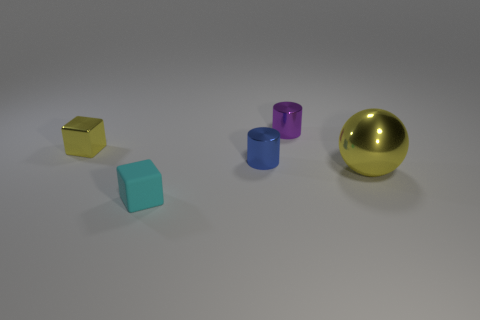Add 5 big brown cylinders. How many objects exist? 10 Subtract all balls. How many objects are left? 4 Add 3 small gray objects. How many small gray objects exist? 3 Subtract 1 blue cylinders. How many objects are left? 4 Subtract all small metallic cylinders. Subtract all small cyan matte cubes. How many objects are left? 2 Add 3 purple metallic things. How many purple metallic things are left? 4 